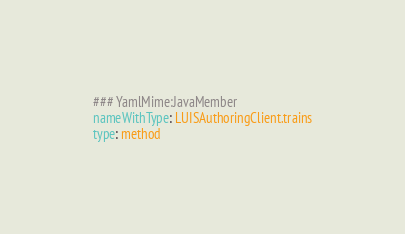<code> <loc_0><loc_0><loc_500><loc_500><_YAML_>### YamlMime:JavaMember
nameWithType: LUISAuthoringClient.trains
type: method</code> 